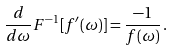<formula> <loc_0><loc_0><loc_500><loc_500>\frac { d } { d \omega } F ^ { - 1 } [ f ^ { \prime } ( \omega ) ] = \frac { - 1 } { f ( \omega ) } \, .</formula> 